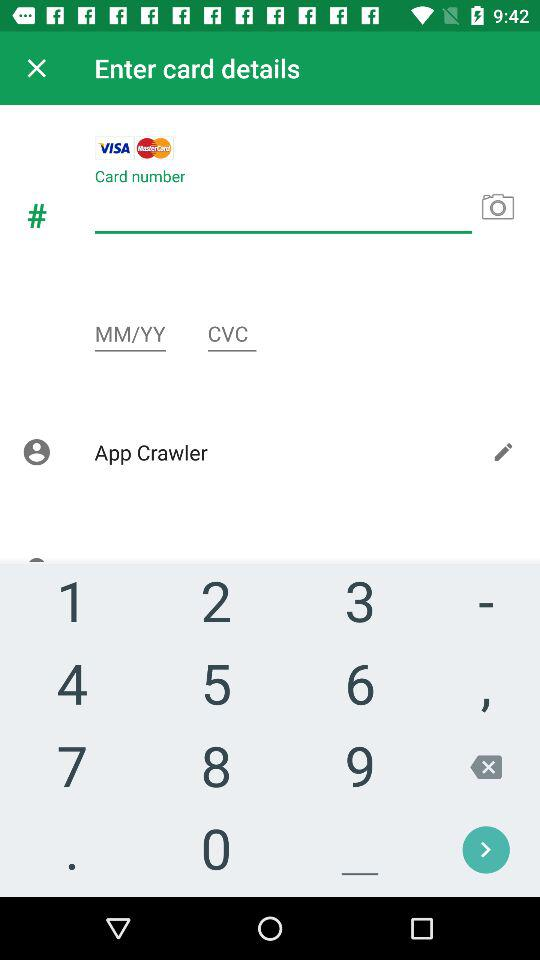How many input fields are there for entering card details?
Answer the question using a single word or phrase. 3 